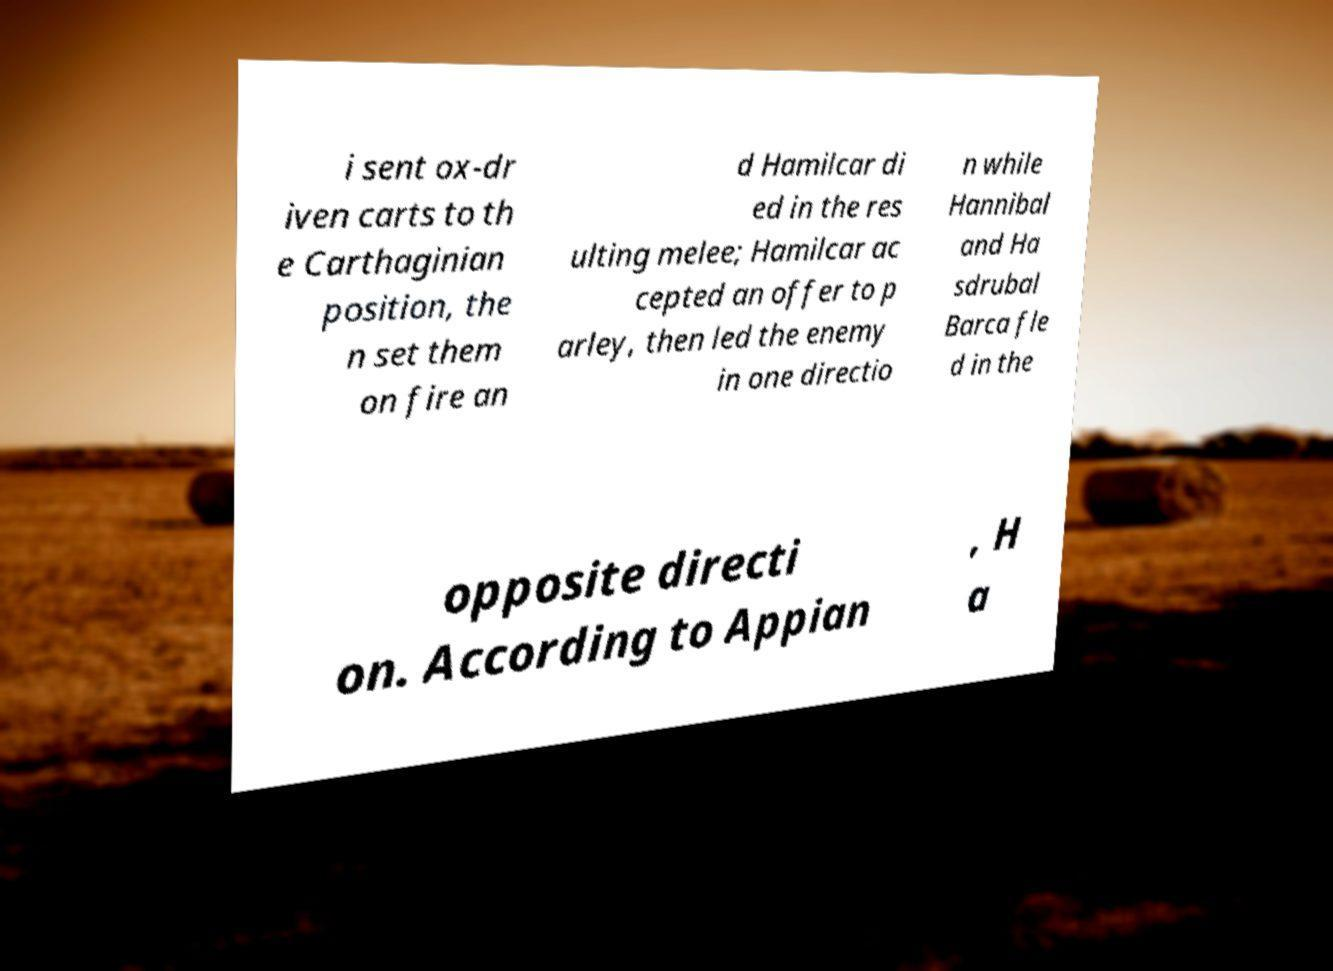Could you extract and type out the text from this image? i sent ox-dr iven carts to th e Carthaginian position, the n set them on fire an d Hamilcar di ed in the res ulting melee; Hamilcar ac cepted an offer to p arley, then led the enemy in one directio n while Hannibal and Ha sdrubal Barca fle d in the opposite directi on. According to Appian , H a 